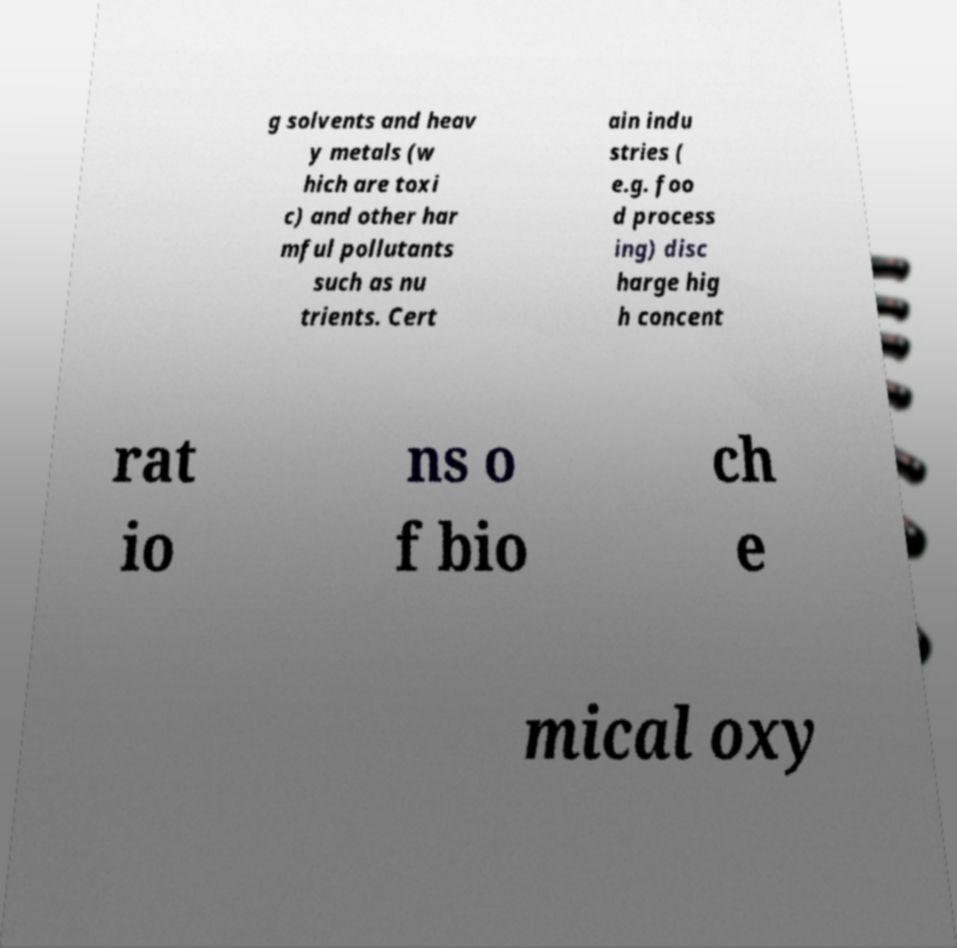I need the written content from this picture converted into text. Can you do that? g solvents and heav y metals (w hich are toxi c) and other har mful pollutants such as nu trients. Cert ain indu stries ( e.g. foo d process ing) disc harge hig h concent rat io ns o f bio ch e mical oxy 